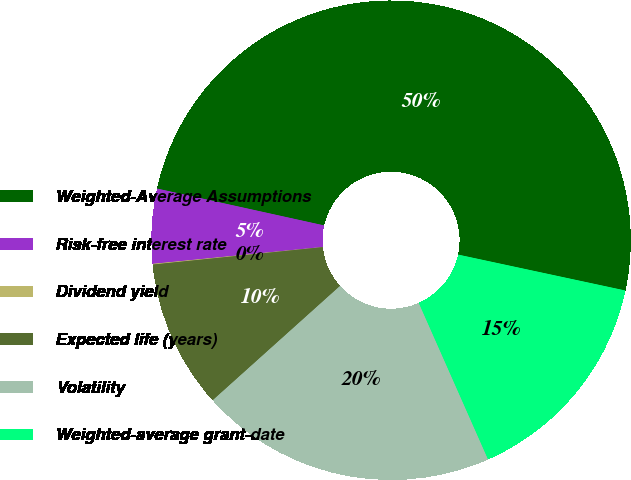<chart> <loc_0><loc_0><loc_500><loc_500><pie_chart><fcel>Weighted-Average Assumptions<fcel>Risk-free interest rate<fcel>Dividend yield<fcel>Expected life (years)<fcel>Volatility<fcel>Weighted-average grant-date<nl><fcel>49.91%<fcel>5.03%<fcel>0.05%<fcel>10.02%<fcel>19.99%<fcel>15.0%<nl></chart> 